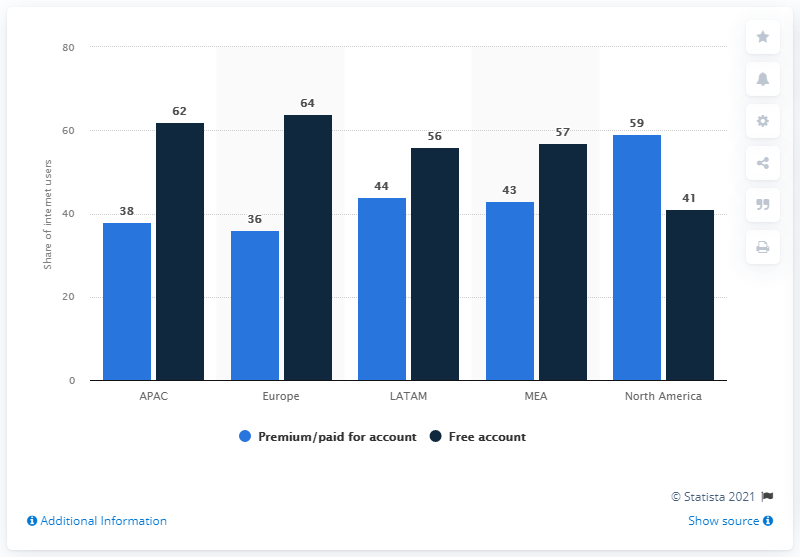Indicate a few pertinent items in this graphic. According to a recent survey, 38% of internet users in APAC countries had a paid Apple Music subscription as of a certain date. The sum of the first and last bar in the chart is 79. The second largest value in the dark blue bar is 62. In North America, 59% of internet users had a paid Apple Music subscription as of 2021. 